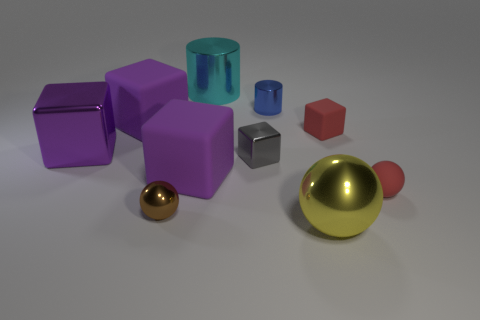Subtract all purple cubes. How many were subtracted if there are1purple cubes left? 2 Subtract all green spheres. How many purple cubes are left? 3 Subtract 1 cubes. How many cubes are left? 4 Subtract all gray cubes. How many cubes are left? 4 Subtract all big metallic blocks. How many blocks are left? 4 Subtract all cyan blocks. Subtract all gray cylinders. How many blocks are left? 5 Subtract all cylinders. How many objects are left? 8 Subtract all big blue cubes. Subtract all large yellow metal objects. How many objects are left? 9 Add 8 gray cubes. How many gray cubes are left? 9 Add 6 tiny blue metallic objects. How many tiny blue metallic objects exist? 7 